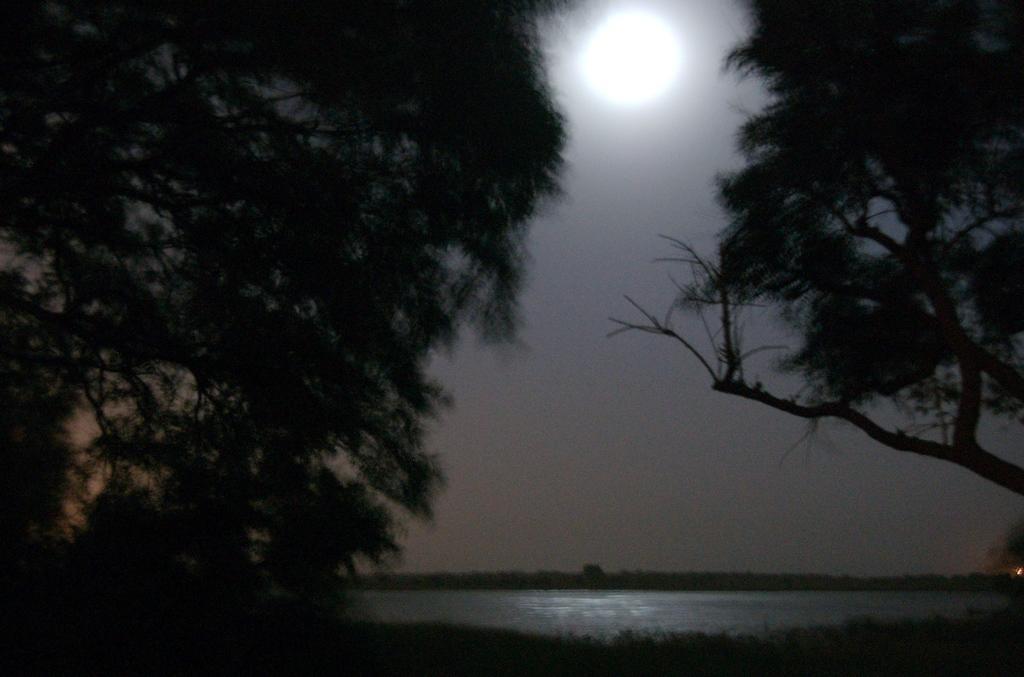Can you describe this image briefly? This picture is clicked outside city. In the foreground we can see a water body. In the background there is a moon in the sky and we can see the trees. 